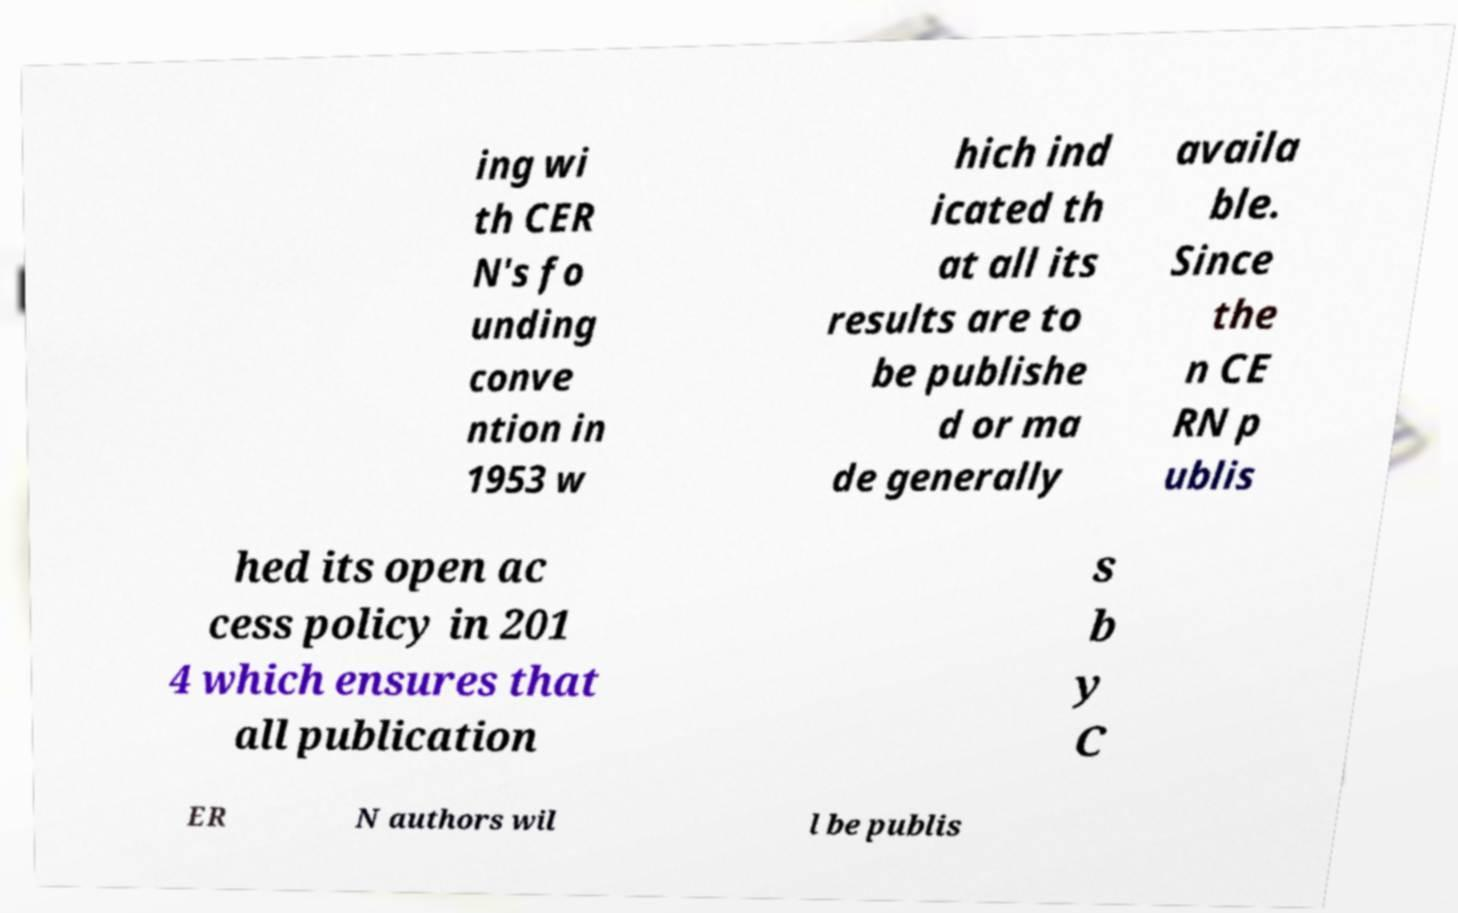For documentation purposes, I need the text within this image transcribed. Could you provide that? ing wi th CER N's fo unding conve ntion in 1953 w hich ind icated th at all its results are to be publishe d or ma de generally availa ble. Since the n CE RN p ublis hed its open ac cess policy in 201 4 which ensures that all publication s b y C ER N authors wil l be publis 